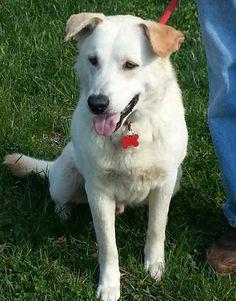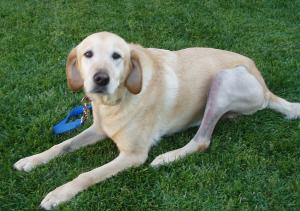The first image is the image on the left, the second image is the image on the right. For the images shown, is this caption "There are four dogs in total." true? Answer yes or no. No. The first image is the image on the left, the second image is the image on the right. Evaluate the accuracy of this statement regarding the images: "The right image contains two dogs.". Is it true? Answer yes or no. No. 